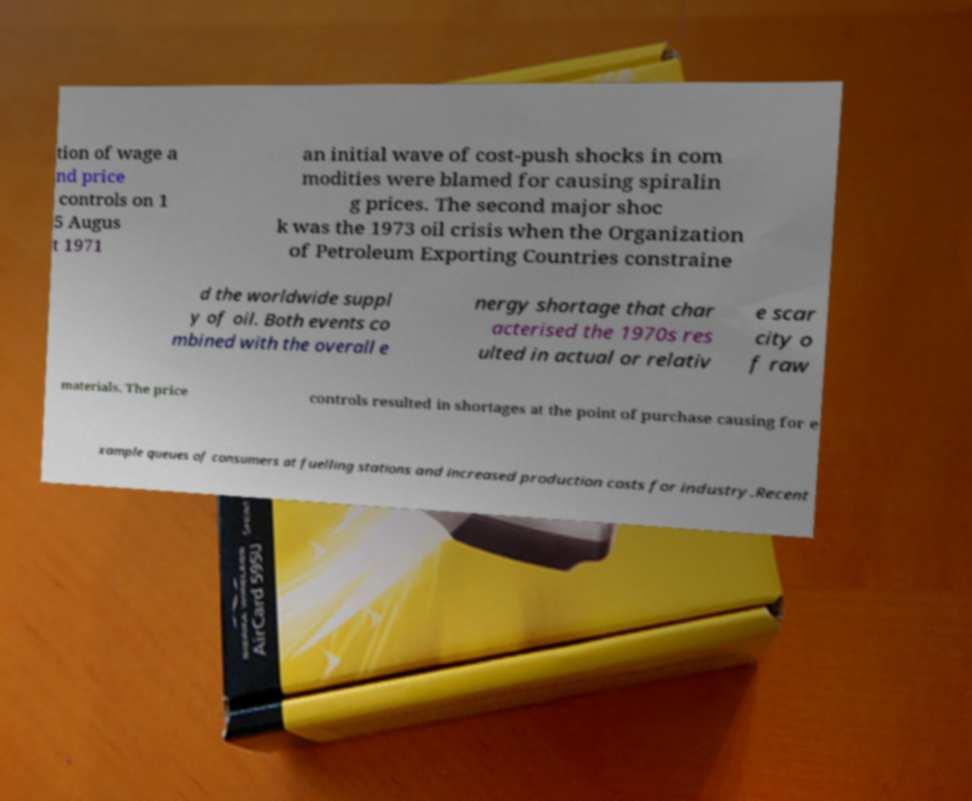Could you assist in decoding the text presented in this image and type it out clearly? tion of wage a nd price controls on 1 5 Augus t 1971 an initial wave of cost-push shocks in com modities were blamed for causing spiralin g prices. The second major shoc k was the 1973 oil crisis when the Organization of Petroleum Exporting Countries constraine d the worldwide suppl y of oil. Both events co mbined with the overall e nergy shortage that char acterised the 1970s res ulted in actual or relativ e scar city o f raw materials. The price controls resulted in shortages at the point of purchase causing for e xample queues of consumers at fuelling stations and increased production costs for industry.Recent 